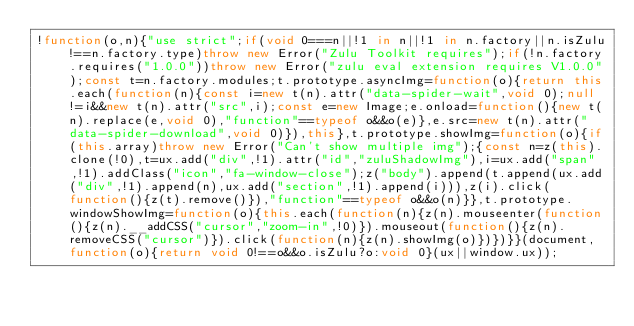<code> <loc_0><loc_0><loc_500><loc_500><_JavaScript_>!function(o,n){"use strict";if(void 0===n||!1 in n||!1 in n.factory||n.isZulu!==n.factory.type)throw new Error("Zulu Toolkit requires");if(!n.factory.requires("1.0.0"))throw new Error("zulu eval extension requires V1.0.0");const t=n.factory.modules;t.prototype.asyncImg=function(o){return this.each(function(n){const i=new t(n).attr("data-spider-wait",void 0);null!=i&&new t(n).attr("src",i);const e=new Image;e.onload=function(){new t(n).replace(e,void 0),"function"==typeof o&&o(e)},e.src=new t(n).attr("data-spider-download",void 0)}),this},t.prototype.showImg=function(o){if(this.array)throw new Error("Can't show multiple img");{const n=z(this).clone(!0),t=ux.add("div",!1).attr("id","zuluShadowImg"),i=ux.add("span",!1).addClass("icon","fa-window-close");z("body").append(t.append(ux.add("div",!1).append(n),ux.add("section",!1).append(i))),z(i).click(function(){z(t).remove()}),"function"==typeof o&&o(n)}},t.prototype.windowShowImg=function(o){this.each(function(n){z(n).mouseenter(function(){z(n).__addCSS("cursor","zoom-in",!0)}).mouseout(function(){z(n).removeCSS("cursor")}).click(function(n){z(n).showImg(o)})})}}(document,function(o){return void 0!==o&&o.isZulu?o:void 0}(ux||window.ux));
</code> 